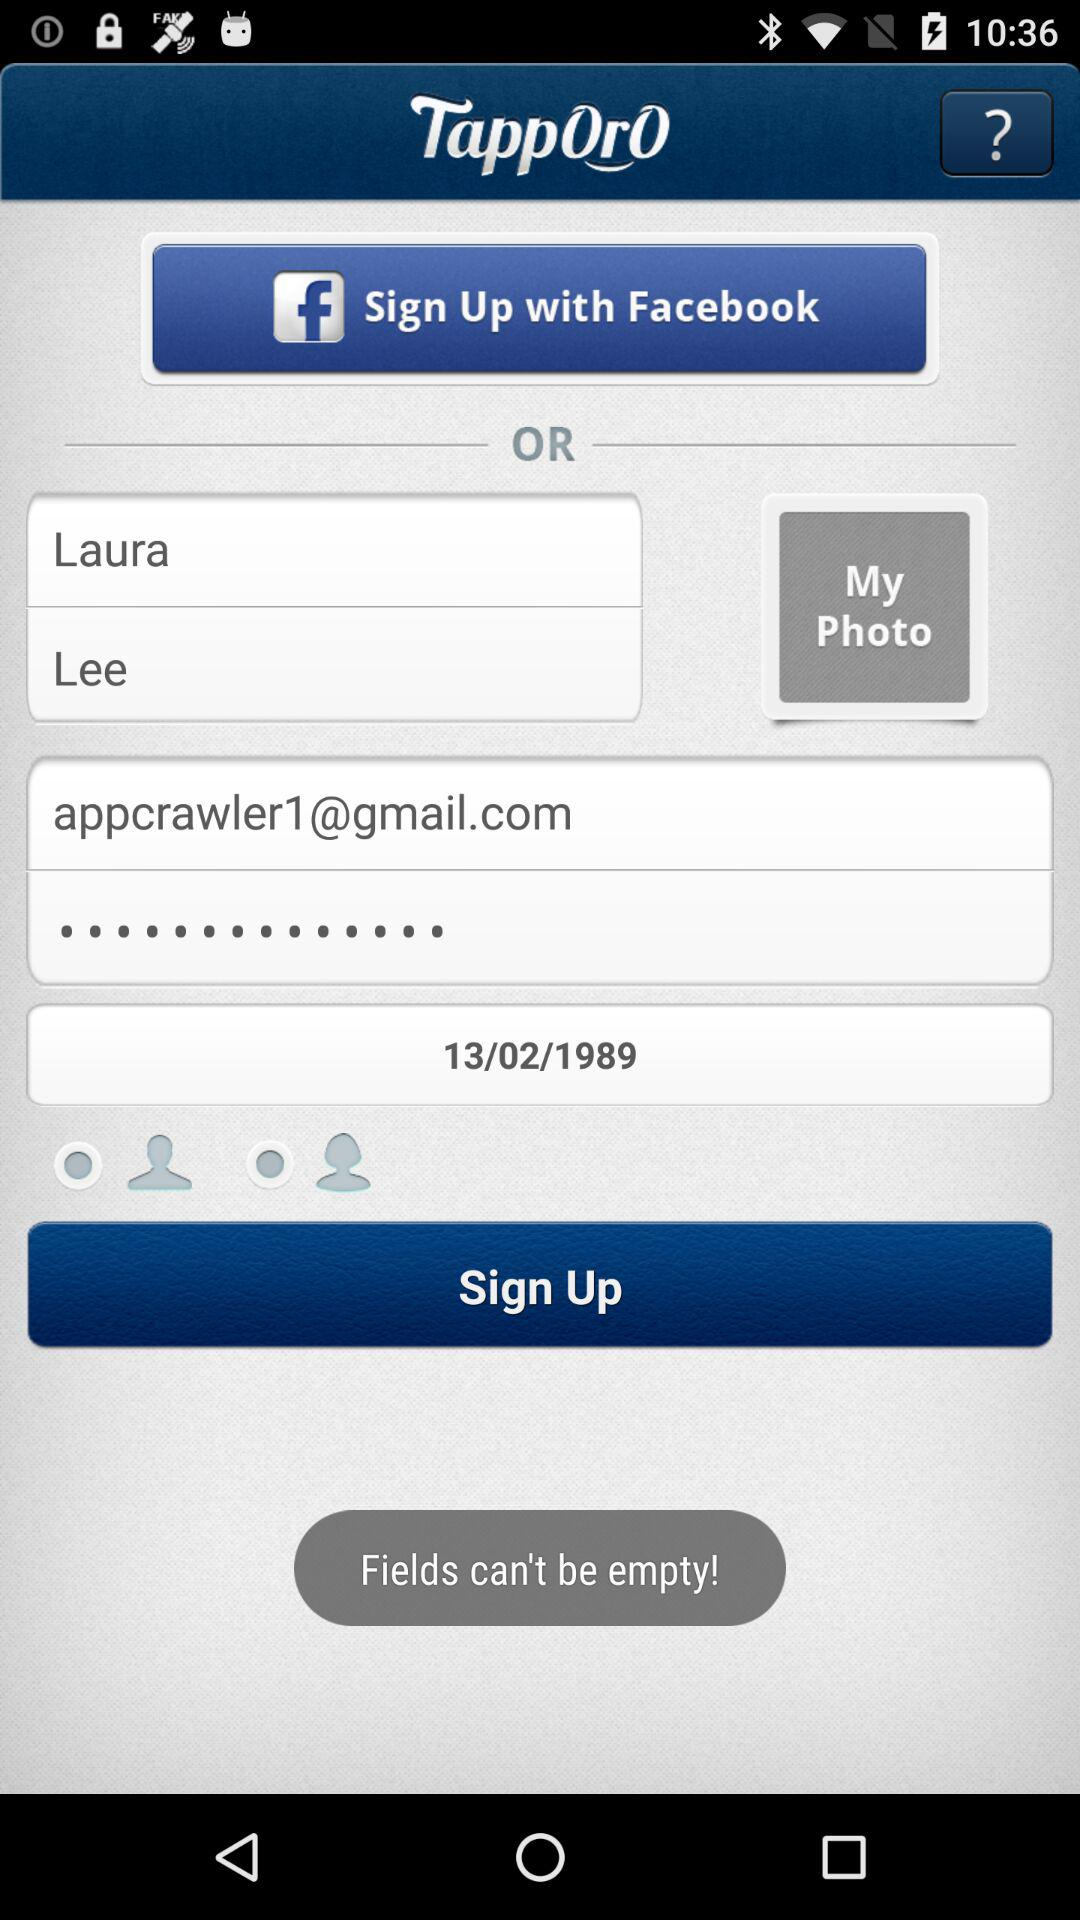What name is used for signing up? The name used for signing up is Laura Lee. 